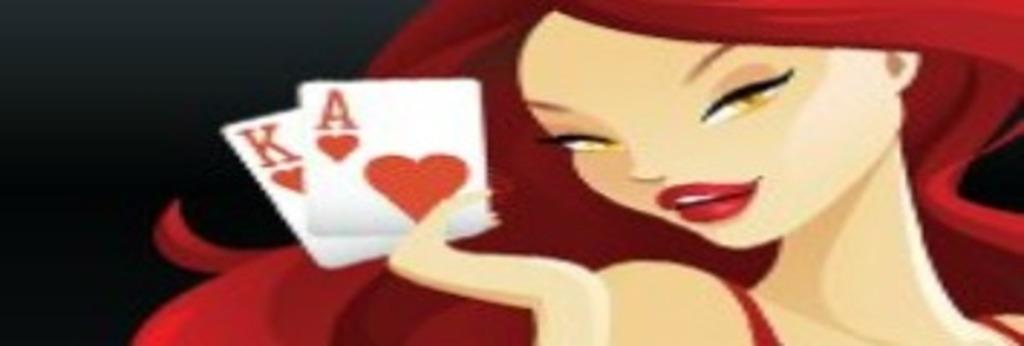What type of image is being described? The image is animated. Who is the main subject in the image? There is a girl in the image. What is the girl holding in her hands? The girl is holding playing cards in her hands. Where is the girl positioned in the image? The girl is on the right side of the image. What color is the background of the image? The background of the image is black. Is there a carriage visible in the image? No, there is no carriage present in the image. Are the girl and another person engaged in a fight in the image? No, there is no fight depicted in the image; the girl is simply holding playing cards. 